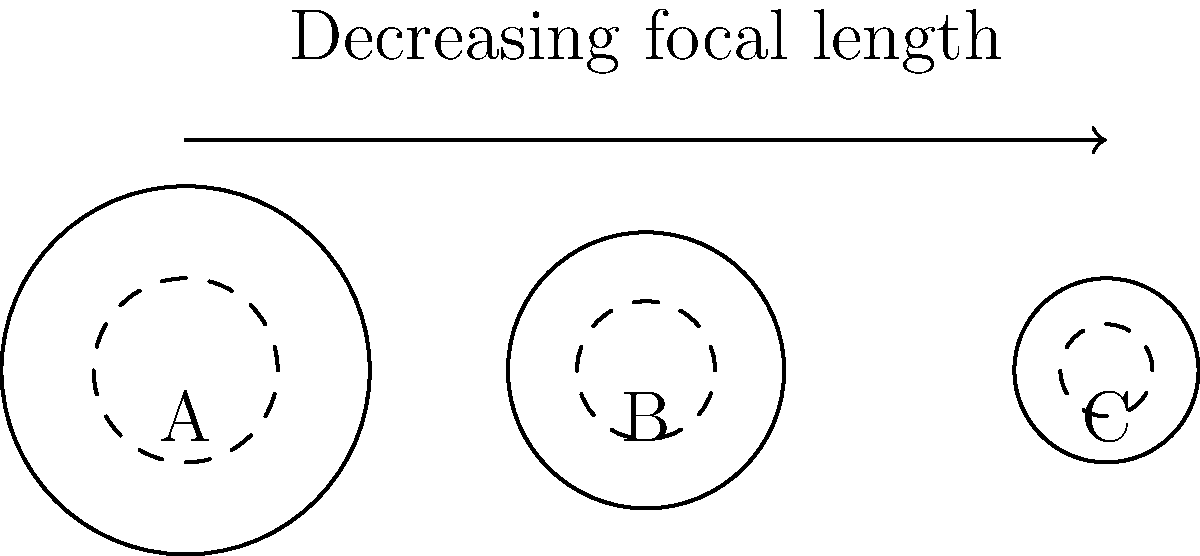Based on the diagram showing three different lens shapes for hidden cameras, which type is most likely to have the widest field of view? To determine which lens type has the widest field of view, we need to consider the relationship between lens shape and focal length:

1. The diagram shows three lens shapes labeled A, B, and C.
2. The arrow indicates decreasing focal length from left to right.
3. Lens A has the largest overall diameter and curvature.
4. Lens B has a medium diameter and curvature.
5. Lens C has the smallest diameter and curvature.
6. A shorter focal length corresponds to a wider field of view.
7. The lens with the shortest focal length (rightmost in the diagram) will have the widest field of view.
8. Therefore, lens C, with the smallest diameter and curvature, has the shortest focal length and widest field of view.

This design allows for a more compact hidden camera while maintaining a wide area of coverage, which is ideal for covert surveillance applications.
Answer: C 